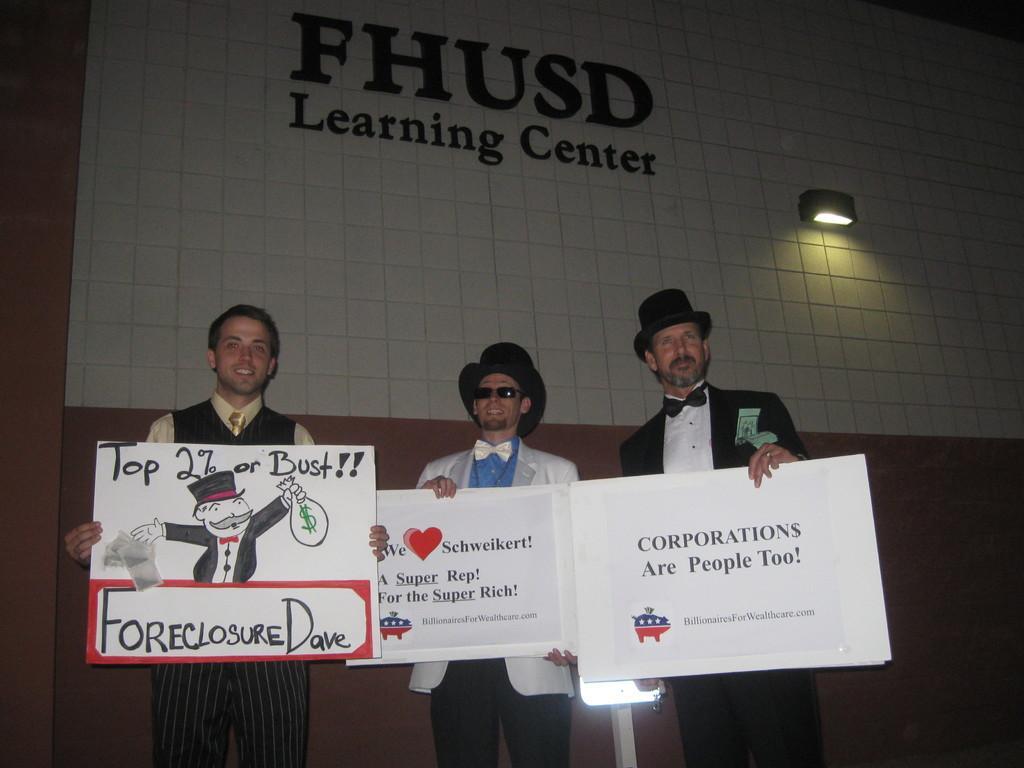In one or two sentences, can you explain what this image depicts? In this image I can see three persons standing and holding few boards. The boards are in white color, background I can see a board in white color and something written on the board and I can see a light. 